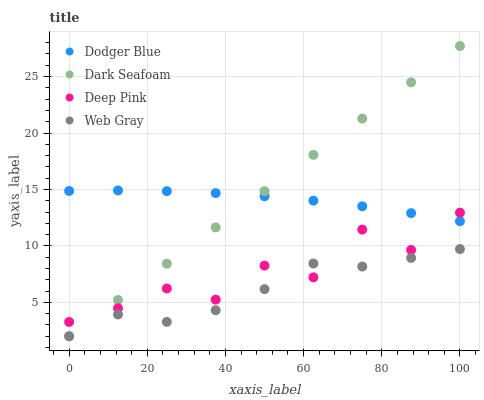Does Web Gray have the minimum area under the curve?
Answer yes or no. Yes. Does Dark Seafoam have the maximum area under the curve?
Answer yes or no. Yes. Does Deep Pink have the minimum area under the curve?
Answer yes or no. No. Does Deep Pink have the maximum area under the curve?
Answer yes or no. No. Is Dark Seafoam the smoothest?
Answer yes or no. Yes. Is Deep Pink the roughest?
Answer yes or no. Yes. Is Deep Pink the smoothest?
Answer yes or no. No. Is Dark Seafoam the roughest?
Answer yes or no. No. Does Web Gray have the lowest value?
Answer yes or no. Yes. Does Deep Pink have the lowest value?
Answer yes or no. No. Does Dark Seafoam have the highest value?
Answer yes or no. Yes. Does Deep Pink have the highest value?
Answer yes or no. No. Is Web Gray less than Dodger Blue?
Answer yes or no. Yes. Is Dodger Blue greater than Web Gray?
Answer yes or no. Yes. Does Dark Seafoam intersect Deep Pink?
Answer yes or no. Yes. Is Dark Seafoam less than Deep Pink?
Answer yes or no. No. Is Dark Seafoam greater than Deep Pink?
Answer yes or no. No. Does Web Gray intersect Dodger Blue?
Answer yes or no. No. 